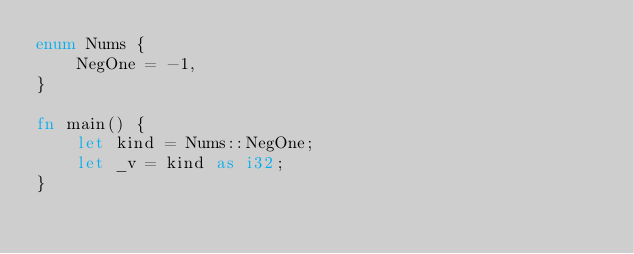Convert code to text. <code><loc_0><loc_0><loc_500><loc_500><_Rust_>enum Nums {
    NegOne = -1,
}

fn main() {
    let kind = Nums::NegOne;
    let _v = kind as i32;
}
</code> 